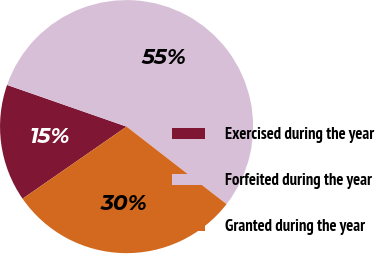<chart> <loc_0><loc_0><loc_500><loc_500><pie_chart><fcel>Exercised during the year<fcel>Forfeited during the year<fcel>Granted during the year<nl><fcel>14.99%<fcel>55.15%<fcel>29.85%<nl></chart> 